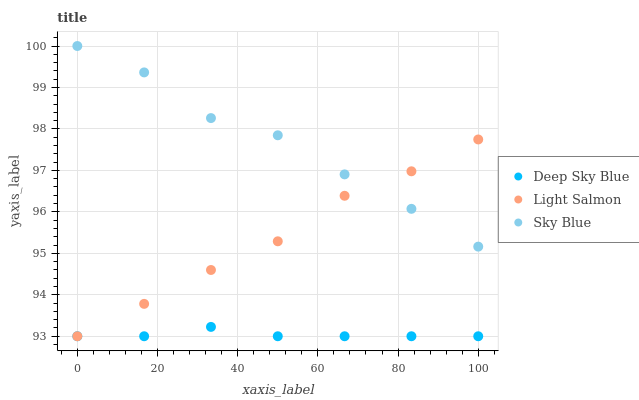Does Deep Sky Blue have the minimum area under the curve?
Answer yes or no. Yes. Does Sky Blue have the maximum area under the curve?
Answer yes or no. Yes. Does Light Salmon have the minimum area under the curve?
Answer yes or no. No. Does Light Salmon have the maximum area under the curve?
Answer yes or no. No. Is Deep Sky Blue the smoothest?
Answer yes or no. Yes. Is Sky Blue the roughest?
Answer yes or no. Yes. Is Light Salmon the smoothest?
Answer yes or no. No. Is Light Salmon the roughest?
Answer yes or no. No. Does Light Salmon have the lowest value?
Answer yes or no. Yes. Does Sky Blue have the highest value?
Answer yes or no. Yes. Does Light Salmon have the highest value?
Answer yes or no. No. Is Deep Sky Blue less than Sky Blue?
Answer yes or no. Yes. Is Sky Blue greater than Deep Sky Blue?
Answer yes or no. Yes. Does Light Salmon intersect Deep Sky Blue?
Answer yes or no. Yes. Is Light Salmon less than Deep Sky Blue?
Answer yes or no. No. Is Light Salmon greater than Deep Sky Blue?
Answer yes or no. No. Does Deep Sky Blue intersect Sky Blue?
Answer yes or no. No. 